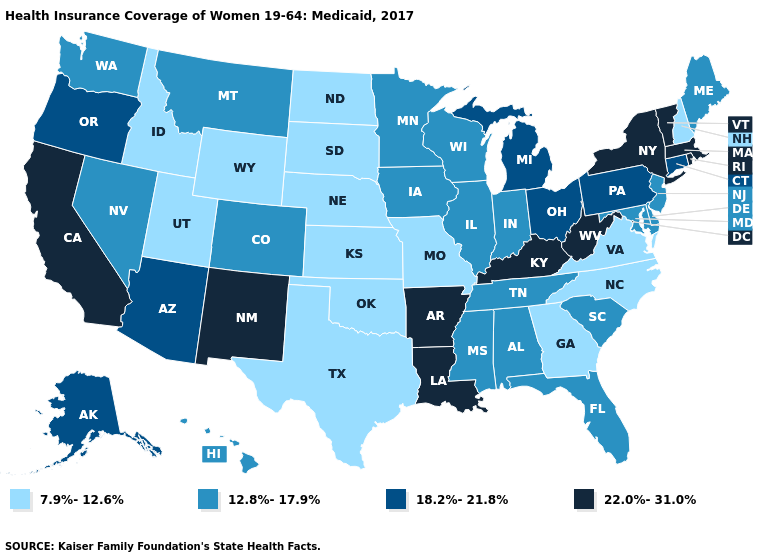What is the value of Wyoming?
Write a very short answer. 7.9%-12.6%. Name the states that have a value in the range 22.0%-31.0%?
Concise answer only. Arkansas, California, Kentucky, Louisiana, Massachusetts, New Mexico, New York, Rhode Island, Vermont, West Virginia. What is the value of Georgia?
Be succinct. 7.9%-12.6%. What is the value of Texas?
Give a very brief answer. 7.9%-12.6%. What is the highest value in states that border Oregon?
Be succinct. 22.0%-31.0%. Name the states that have a value in the range 12.8%-17.9%?
Give a very brief answer. Alabama, Colorado, Delaware, Florida, Hawaii, Illinois, Indiana, Iowa, Maine, Maryland, Minnesota, Mississippi, Montana, Nevada, New Jersey, South Carolina, Tennessee, Washington, Wisconsin. Name the states that have a value in the range 7.9%-12.6%?
Keep it brief. Georgia, Idaho, Kansas, Missouri, Nebraska, New Hampshire, North Carolina, North Dakota, Oklahoma, South Dakota, Texas, Utah, Virginia, Wyoming. Among the states that border Nevada , does Idaho have the highest value?
Answer briefly. No. Which states hav the highest value in the West?
Keep it brief. California, New Mexico. What is the value of Utah?
Concise answer only. 7.9%-12.6%. What is the highest value in the USA?
Keep it brief. 22.0%-31.0%. Name the states that have a value in the range 22.0%-31.0%?
Short answer required. Arkansas, California, Kentucky, Louisiana, Massachusetts, New Mexico, New York, Rhode Island, Vermont, West Virginia. Name the states that have a value in the range 22.0%-31.0%?
Quick response, please. Arkansas, California, Kentucky, Louisiana, Massachusetts, New Mexico, New York, Rhode Island, Vermont, West Virginia. What is the lowest value in the USA?
Answer briefly. 7.9%-12.6%. What is the lowest value in states that border Florida?
Give a very brief answer. 7.9%-12.6%. 